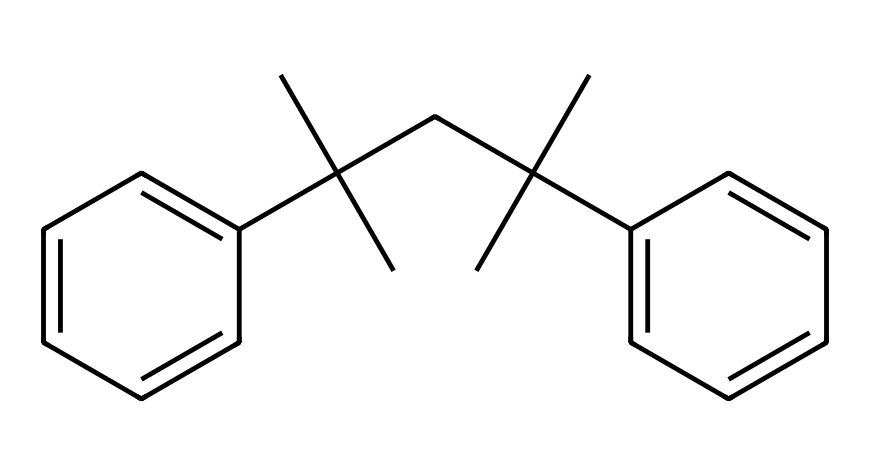How many carbon atoms are in the compound? By analyzing the SMILES representation, we can count the number of 'C' characters, which represent carbon atoms. The depicted structure has multiple branching points and aromatic rings where each 'C' accounts for one carbon atom. Upon careful counting, there are 18 carbon atoms in total.
Answer: 18 What is the primary feature of this chemical structure? The significant characteristic of this structure is the presence of long carbon chains and aromatic rings, specifically two phenyl groups attached to a tertiary carbon. These features are indicative of polystyrene, which has a distinctive rigid structure enhancing its protective properties for items such as sports cards.
Answer: rigidity Is this chemical predominantly polar or nonpolar? The structure consists mainly of carbon and hydrogen, typically associated with nonpolar bonds due to the similar electronegativities of these elements. The overall symmetry and lack of polar functional groups further contribute to classifying it as nonpolar.
Answer: nonpolar How many double bonds are present in the structure? In the SMILES representation, each 'c' indicates a carbon in an aromatic ring where there are implied double bonds between adjacent carbons. Given the structure includes two aromatic rings (phenyl groups), there will be numerous double bonds present. In total, there are 6 significant double bonds in the aromatic rings.
Answer: 6 What type of plastic does this compound represent? This chemical is identified as polystyrene, categorized under thermoplastics due to its versatility. Its structure allows for significant applications in protective casings, offering strength and temperature stability, which is valuable for safeguarding collectibles like sports cards.
Answer: polystyrene Does this compound have any functional groups? Upon reviewing the SMILES string, we notice it lacks any typical functional groups like hydroxyl (-OH) or carboxyl (-COOH), emphasizing that it is primarily composed of hydrocarbons. Thus, the molecule consists mainly of simple carbon and hydrogen components without any functional substitutions.
Answer: no 